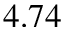Convert formula to latex. <formula><loc_0><loc_0><loc_500><loc_500>4 . 7 4</formula> 